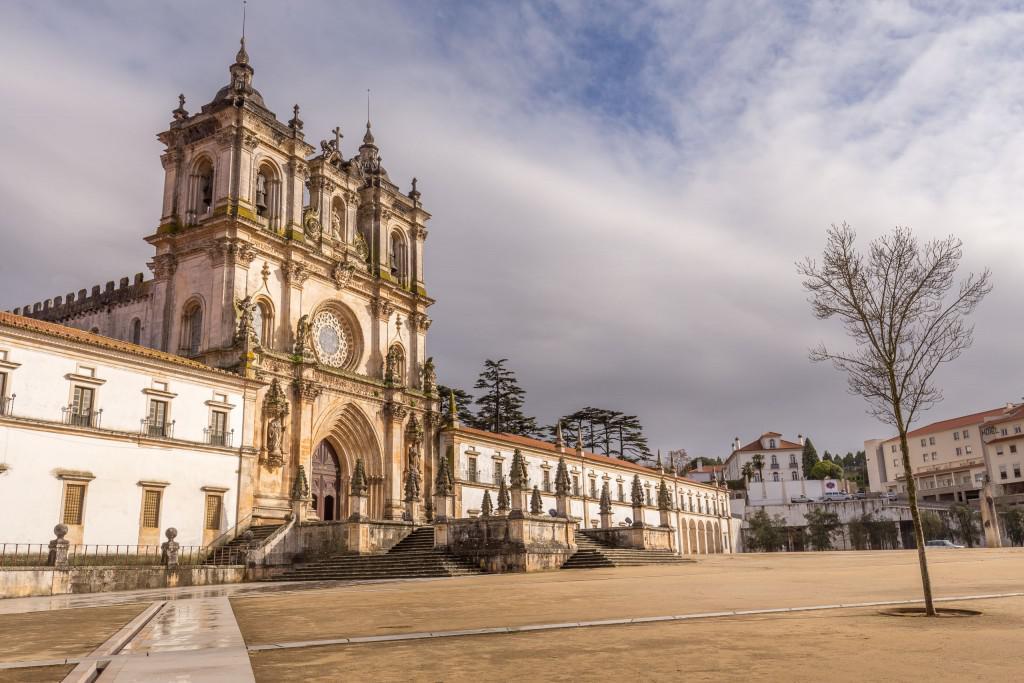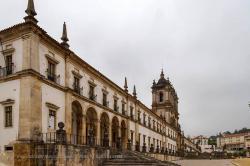The first image is the image on the left, the second image is the image on the right. Considering the images on both sides, is "A notched wall is behind an ornate facade with a circle above an arch, in one image." valid? Answer yes or no. Yes. The first image is the image on the left, the second image is the image on the right. Considering the images on both sides, is "In one of the photos, there is at least one tree pictured in front of the buildings." valid? Answer yes or no. Yes. 